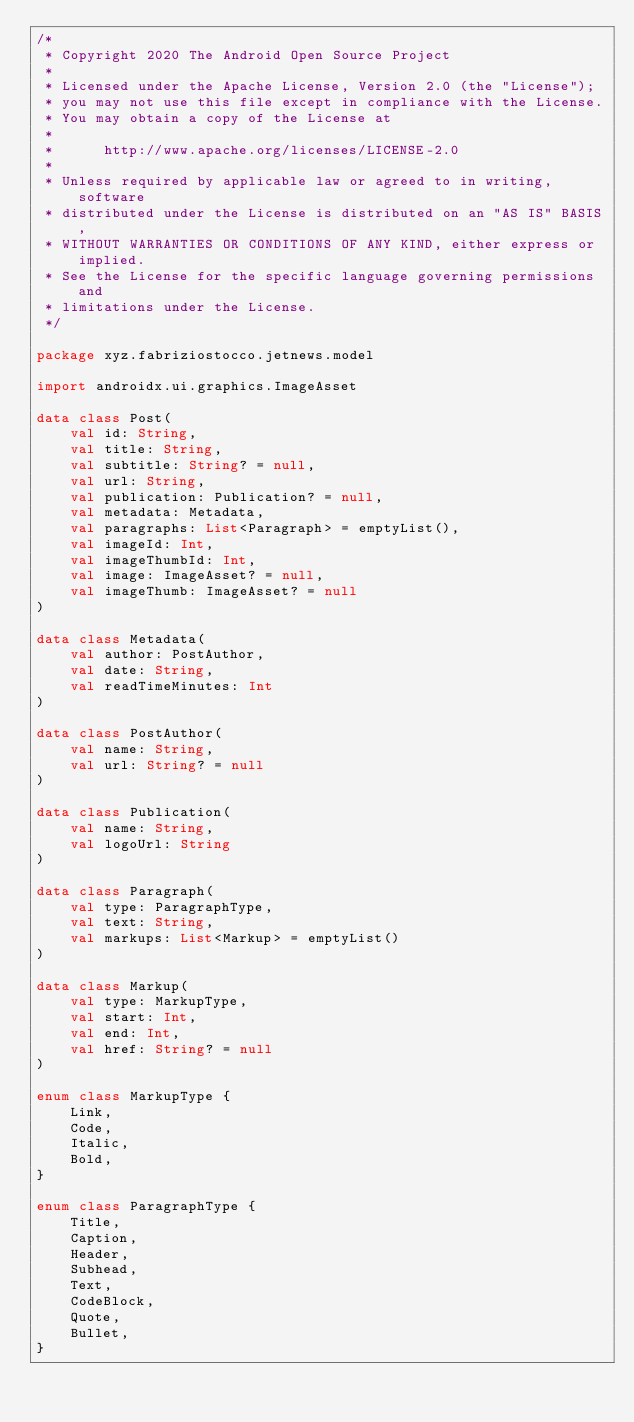Convert code to text. <code><loc_0><loc_0><loc_500><loc_500><_Kotlin_>/*
 * Copyright 2020 The Android Open Source Project
 *
 * Licensed under the Apache License, Version 2.0 (the "License");
 * you may not use this file except in compliance with the License.
 * You may obtain a copy of the License at
 *
 *      http://www.apache.org/licenses/LICENSE-2.0
 *
 * Unless required by applicable law or agreed to in writing, software
 * distributed under the License is distributed on an "AS IS" BASIS,
 * WITHOUT WARRANTIES OR CONDITIONS OF ANY KIND, either express or implied.
 * See the License for the specific language governing permissions and
 * limitations under the License.
 */

package xyz.fabriziostocco.jetnews.model

import androidx.ui.graphics.ImageAsset

data class Post(
    val id: String,
    val title: String,
    val subtitle: String? = null,
    val url: String,
    val publication: Publication? = null,
    val metadata: Metadata,
    val paragraphs: List<Paragraph> = emptyList(),
    val imageId: Int,
    val imageThumbId: Int,
    val image: ImageAsset? = null,
    val imageThumb: ImageAsset? = null
)

data class Metadata(
    val author: PostAuthor,
    val date: String,
    val readTimeMinutes: Int
)

data class PostAuthor(
    val name: String,
    val url: String? = null
)

data class Publication(
    val name: String,
    val logoUrl: String
)

data class Paragraph(
    val type: ParagraphType,
    val text: String,
    val markups: List<Markup> = emptyList()
)

data class Markup(
    val type: MarkupType,
    val start: Int,
    val end: Int,
    val href: String? = null
)

enum class MarkupType {
    Link,
    Code,
    Italic,
    Bold,
}

enum class ParagraphType {
    Title,
    Caption,
    Header,
    Subhead,
    Text,
    CodeBlock,
    Quote,
    Bullet,
}
</code> 